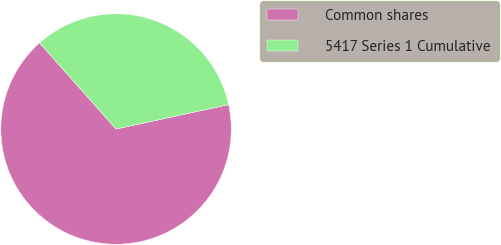Convert chart to OTSL. <chart><loc_0><loc_0><loc_500><loc_500><pie_chart><fcel>Common shares<fcel>5417 Series 1 Cumulative<nl><fcel>66.83%<fcel>33.17%<nl></chart> 